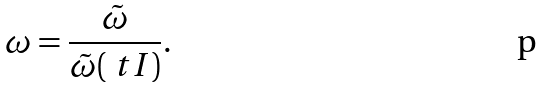<formula> <loc_0><loc_0><loc_500><loc_500>\omega = \frac { \tilde { \omega } } { \tilde { \omega } ( \ t I ) } .</formula> 